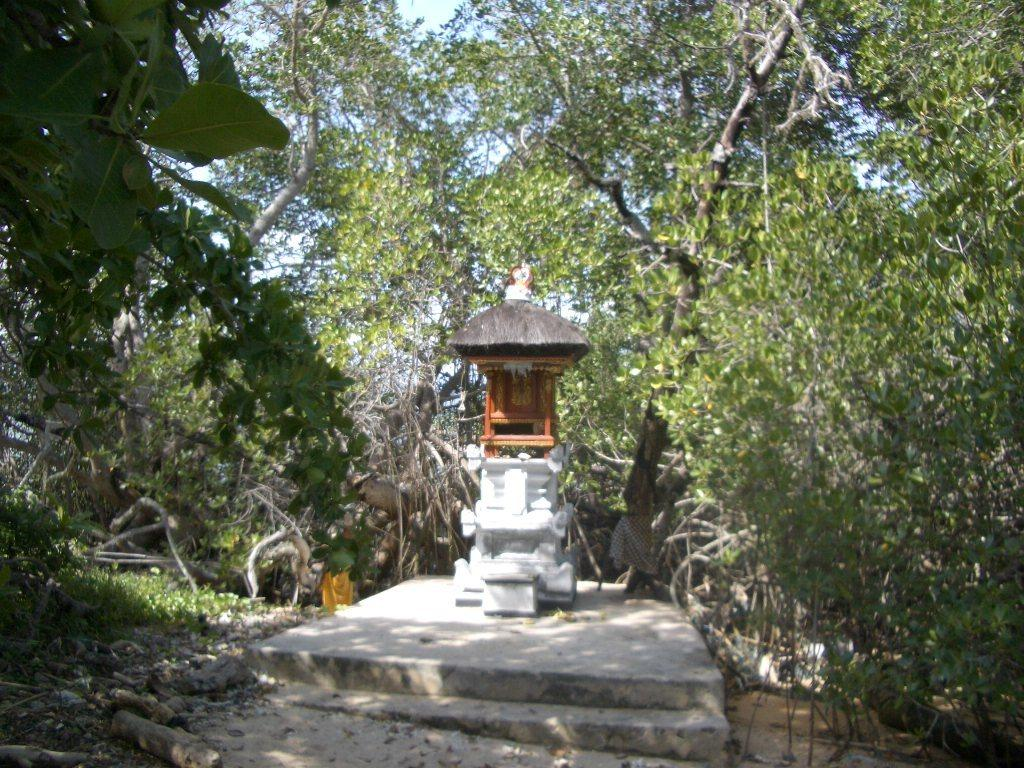What type of structure is depicted in the image? There is a temple-like roof in the image. What can be seen surrounding the roof? There are plants and trees around the roof. How many cherries are hanging from the trees in the image? There is no mention of cherries in the image, so we cannot determine the number of cherries present. 